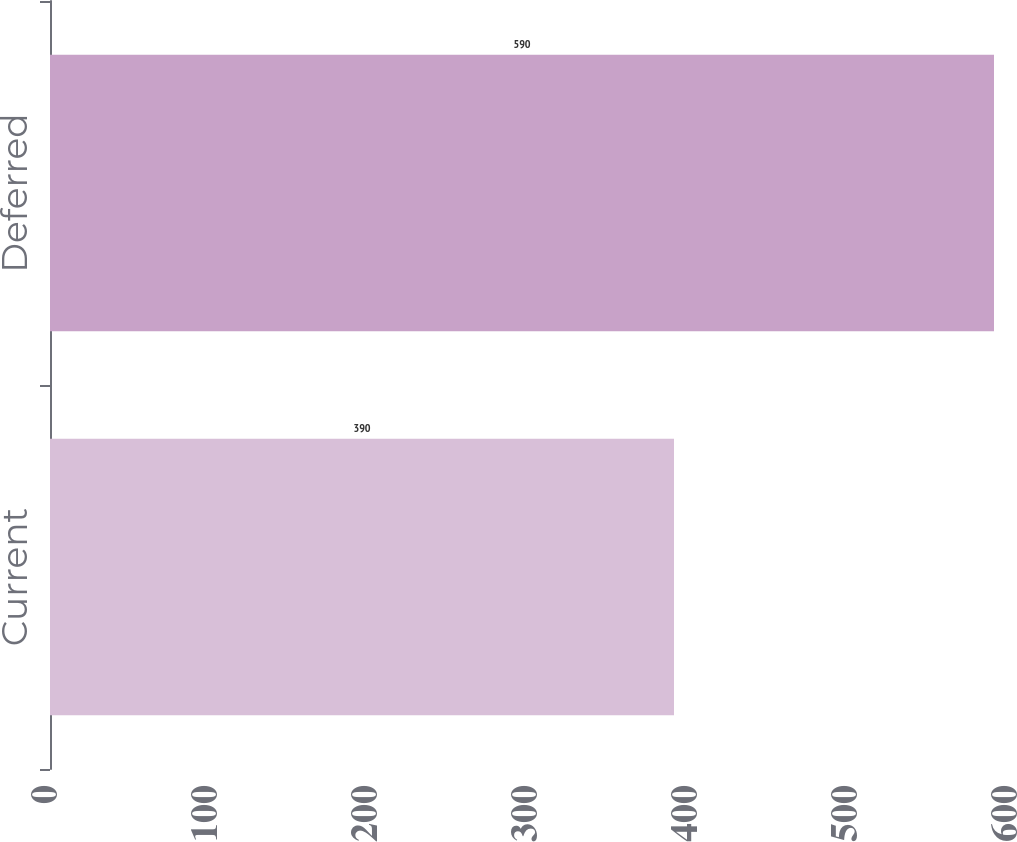Convert chart to OTSL. <chart><loc_0><loc_0><loc_500><loc_500><bar_chart><fcel>Current<fcel>Deferred<nl><fcel>390<fcel>590<nl></chart> 